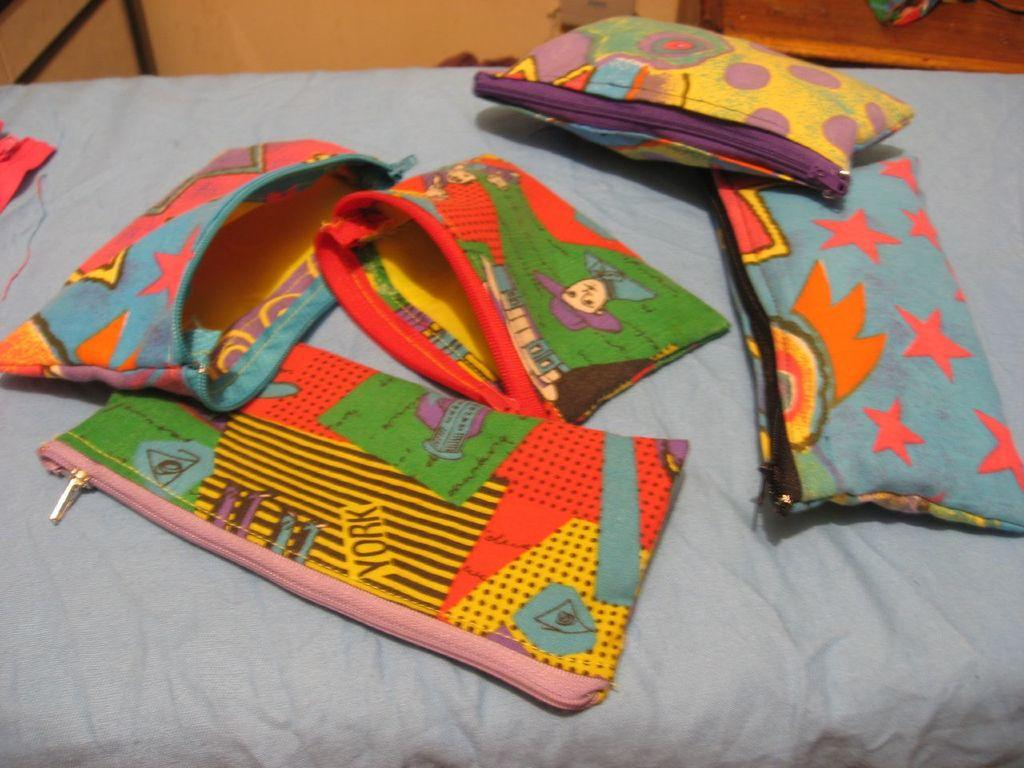What objects are present in the image? There are bags in the image. How are the bags positioned in the image? The bags are placed on a coat. Can you see a monkey holding a note on the sidewalk in the image? No, there is no monkey, note, or sidewalk present in the image. 